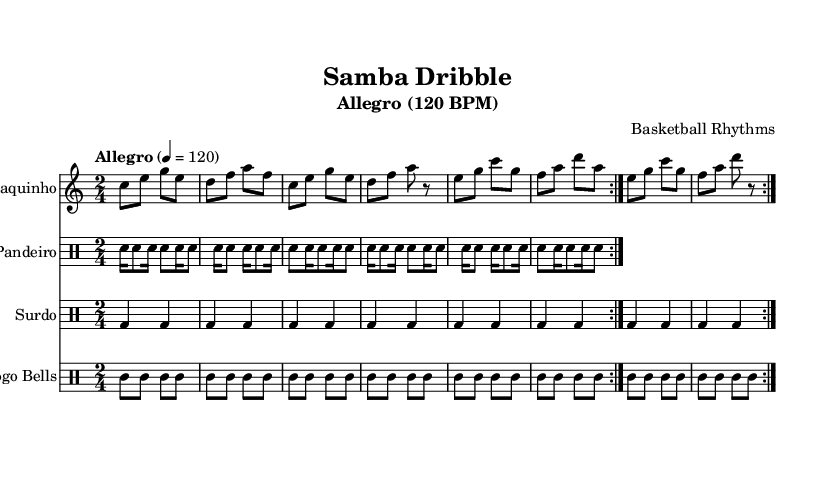What is the key signature of this music? The key signature is C major, which has no sharps or flats.
Answer: C major What is the time signature of this music? The time signature is indicated at the beginning of the score, showing two beats per measure.
Answer: 2/4 What is the tempo marking of this piece? The tempo marking specifies "Allegro," which indicates a fast tempo, and is written as 4 equals 120 beats per minute.
Answer: Allegro How many measures are repeated in the cavaquinho part? The cavaquinho part instructs to repeat the section two times, as indicated by the repeat signs.
Answer: 2 Which instruments are included in the score? The score includes four instruments: cavaquinho, pandeiro, surdo, and agogo bells, as mentioned at the beginning of each staff.
Answer: Cavaquinho, pandeiro, surdo, agogo bells What rhythm pattern is primarily used in the pandeiro section? The pandeiro section features a repeated pattern of sixteenth notes followed by eighth notes, creating a rhythmic bounce typical of samba.
Answer: Snare Explain the main rhythmic characteristic of the surdo part. The surdo part maintains a simple rhythmic pattern with a steady beat, emphasizing the downbeats of the measure, essential for keeping time in samba music.
Answer: Steady beat 